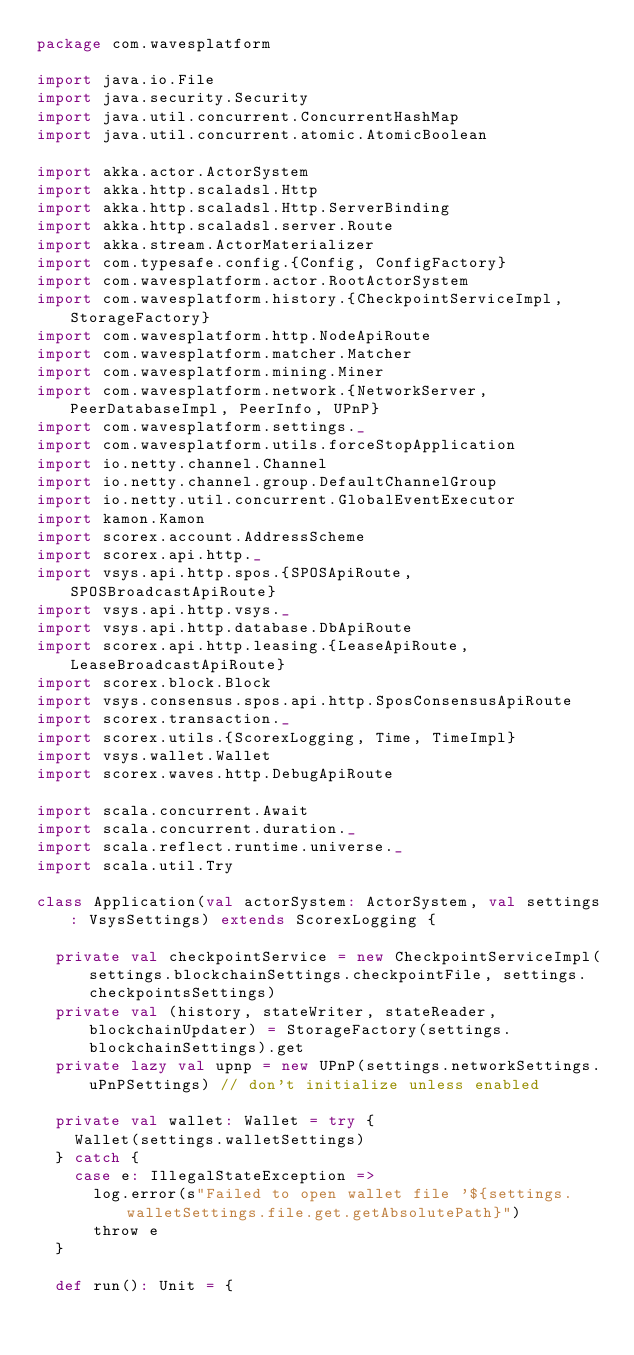<code> <loc_0><loc_0><loc_500><loc_500><_Scala_>package com.wavesplatform

import java.io.File
import java.security.Security
import java.util.concurrent.ConcurrentHashMap
import java.util.concurrent.atomic.AtomicBoolean

import akka.actor.ActorSystem
import akka.http.scaladsl.Http
import akka.http.scaladsl.Http.ServerBinding
import akka.http.scaladsl.server.Route
import akka.stream.ActorMaterializer
import com.typesafe.config.{Config, ConfigFactory}
import com.wavesplatform.actor.RootActorSystem
import com.wavesplatform.history.{CheckpointServiceImpl, StorageFactory}
import com.wavesplatform.http.NodeApiRoute
import com.wavesplatform.matcher.Matcher
import com.wavesplatform.mining.Miner
import com.wavesplatform.network.{NetworkServer, PeerDatabaseImpl, PeerInfo, UPnP}
import com.wavesplatform.settings._
import com.wavesplatform.utils.forceStopApplication
import io.netty.channel.Channel
import io.netty.channel.group.DefaultChannelGroup
import io.netty.util.concurrent.GlobalEventExecutor
import kamon.Kamon
import scorex.account.AddressScheme
import scorex.api.http._
import vsys.api.http.spos.{SPOSApiRoute, SPOSBroadcastApiRoute}
import vsys.api.http.vsys._
import vsys.api.http.database.DbApiRoute
import scorex.api.http.leasing.{LeaseApiRoute, LeaseBroadcastApiRoute}
import scorex.block.Block
import vsys.consensus.spos.api.http.SposConsensusApiRoute
import scorex.transaction._
import scorex.utils.{ScorexLogging, Time, TimeImpl}
import vsys.wallet.Wallet
import scorex.waves.http.DebugApiRoute

import scala.concurrent.Await
import scala.concurrent.duration._
import scala.reflect.runtime.universe._
import scala.util.Try

class Application(val actorSystem: ActorSystem, val settings: VsysSettings) extends ScorexLogging {

  private val checkpointService = new CheckpointServiceImpl(settings.blockchainSettings.checkpointFile, settings.checkpointsSettings)
  private val (history, stateWriter, stateReader, blockchainUpdater) = StorageFactory(settings.blockchainSettings).get
  private lazy val upnp = new UPnP(settings.networkSettings.uPnPSettings) // don't initialize unless enabled

  private val wallet: Wallet = try {
    Wallet(settings.walletSettings)
  } catch {
    case e: IllegalStateException =>
      log.error(s"Failed to open wallet file '${settings.walletSettings.file.get.getAbsolutePath}")
      throw e
  }

  def run(): Unit = {</code> 